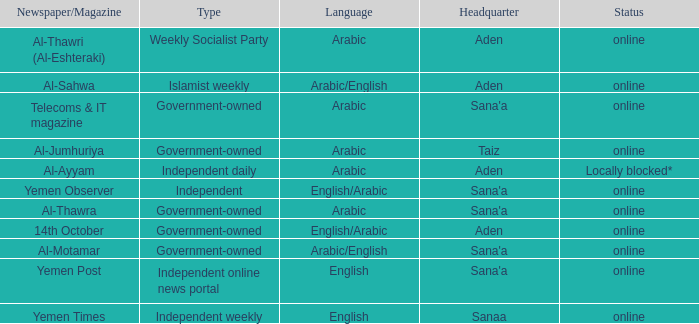What is Headquarter, when Newspaper/Magazine is Al-Ayyam? Aden. 